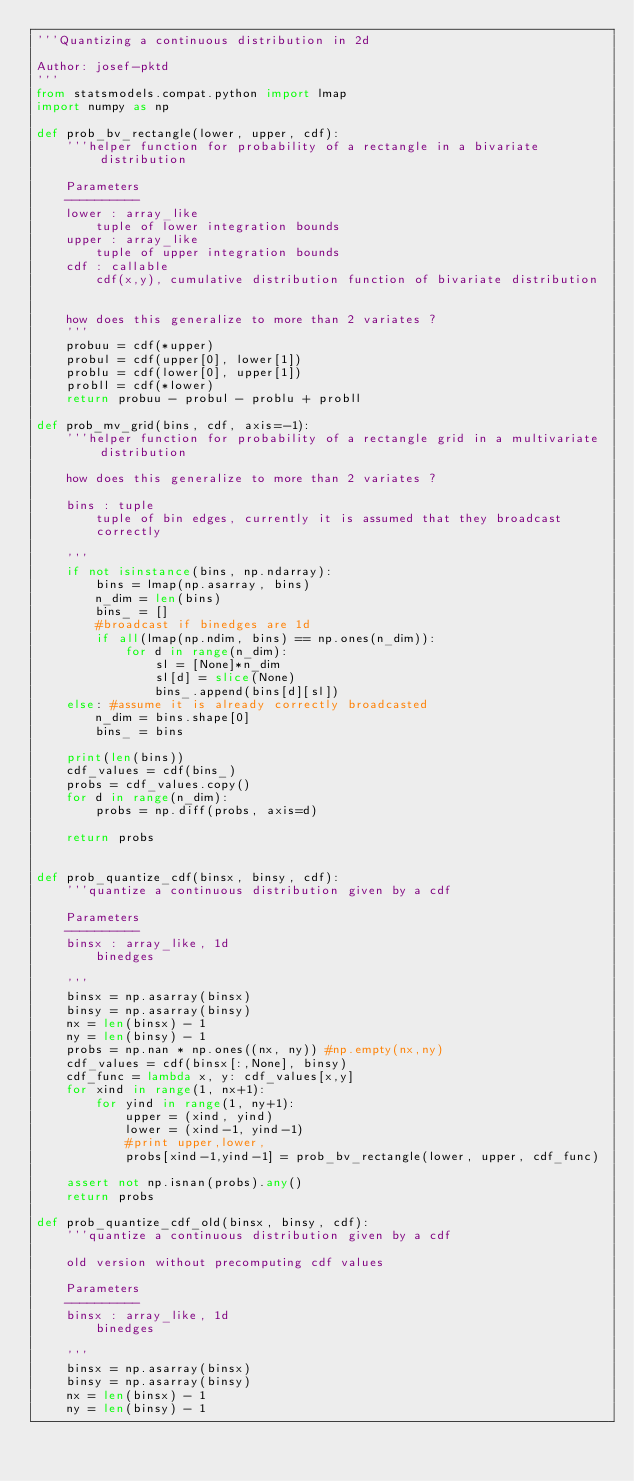<code> <loc_0><loc_0><loc_500><loc_500><_Python_>'''Quantizing a continuous distribution in 2d

Author: josef-pktd
'''
from statsmodels.compat.python import lmap
import numpy as np

def prob_bv_rectangle(lower, upper, cdf):
    '''helper function for probability of a rectangle in a bivariate distribution

    Parameters
    ----------
    lower : array_like
        tuple of lower integration bounds
    upper : array_like
        tuple of upper integration bounds
    cdf : callable
        cdf(x,y), cumulative distribution function of bivariate distribution


    how does this generalize to more than 2 variates ?
    '''
    probuu = cdf(*upper)
    probul = cdf(upper[0], lower[1])
    problu = cdf(lower[0], upper[1])
    probll = cdf(*lower)
    return probuu - probul - problu + probll

def prob_mv_grid(bins, cdf, axis=-1):
    '''helper function for probability of a rectangle grid in a multivariate distribution

    how does this generalize to more than 2 variates ?

    bins : tuple
        tuple of bin edges, currently it is assumed that they broadcast
        correctly

    '''
    if not isinstance(bins, np.ndarray):
        bins = lmap(np.asarray, bins)
        n_dim = len(bins)
        bins_ = []
        #broadcast if binedges are 1d
        if all(lmap(np.ndim, bins) == np.ones(n_dim)):
            for d in range(n_dim):
                sl = [None]*n_dim
                sl[d] = slice(None)
                bins_.append(bins[d][sl])
    else: #assume it is already correctly broadcasted
        n_dim = bins.shape[0]
        bins_ = bins

    print(len(bins))
    cdf_values = cdf(bins_)
    probs = cdf_values.copy()
    for d in range(n_dim):
        probs = np.diff(probs, axis=d)

    return probs


def prob_quantize_cdf(binsx, binsy, cdf):
    '''quantize a continuous distribution given by a cdf

    Parameters
    ----------
    binsx : array_like, 1d
        binedges

    '''
    binsx = np.asarray(binsx)
    binsy = np.asarray(binsy)
    nx = len(binsx) - 1
    ny = len(binsy) - 1
    probs = np.nan * np.ones((nx, ny)) #np.empty(nx,ny)
    cdf_values = cdf(binsx[:,None], binsy)
    cdf_func = lambda x, y: cdf_values[x,y]
    for xind in range(1, nx+1):
        for yind in range(1, ny+1):
            upper = (xind, yind)
            lower = (xind-1, yind-1)
            #print upper,lower,
            probs[xind-1,yind-1] = prob_bv_rectangle(lower, upper, cdf_func)

    assert not np.isnan(probs).any()
    return probs

def prob_quantize_cdf_old(binsx, binsy, cdf):
    '''quantize a continuous distribution given by a cdf

    old version without precomputing cdf values

    Parameters
    ----------
    binsx : array_like, 1d
        binedges

    '''
    binsx = np.asarray(binsx)
    binsy = np.asarray(binsy)
    nx = len(binsx) - 1
    ny = len(binsy) - 1</code> 